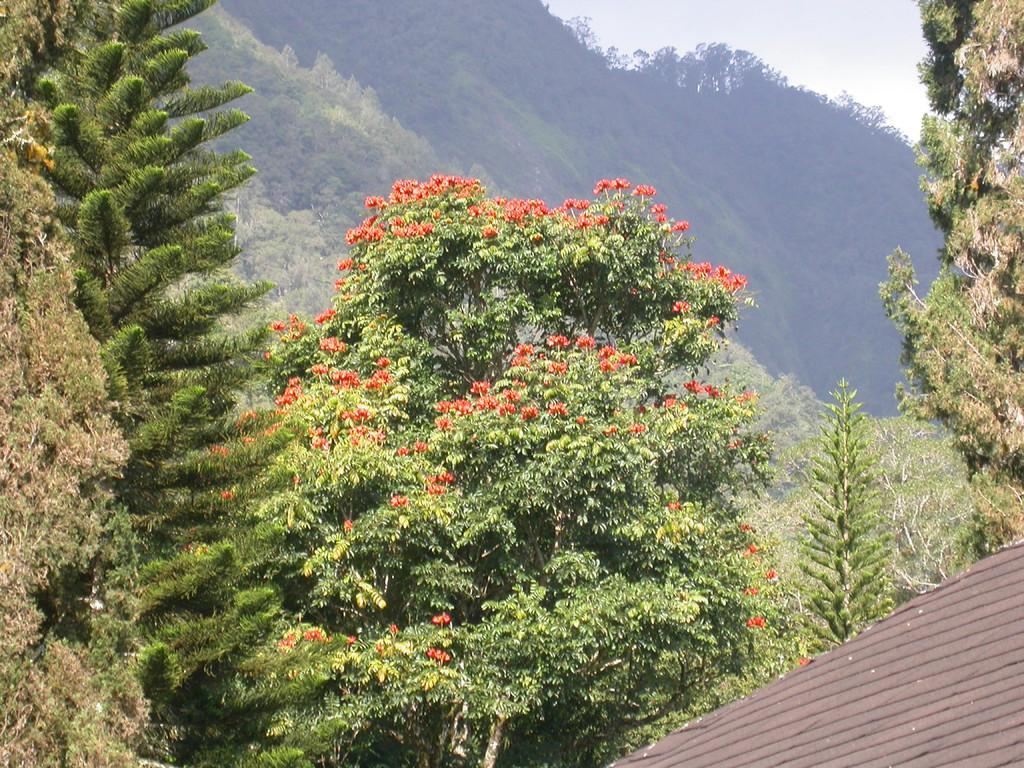In one or two sentences, can you explain what this image depicts? In this image I can see a roof of a building, on the right and there are trees and hills at the back. 